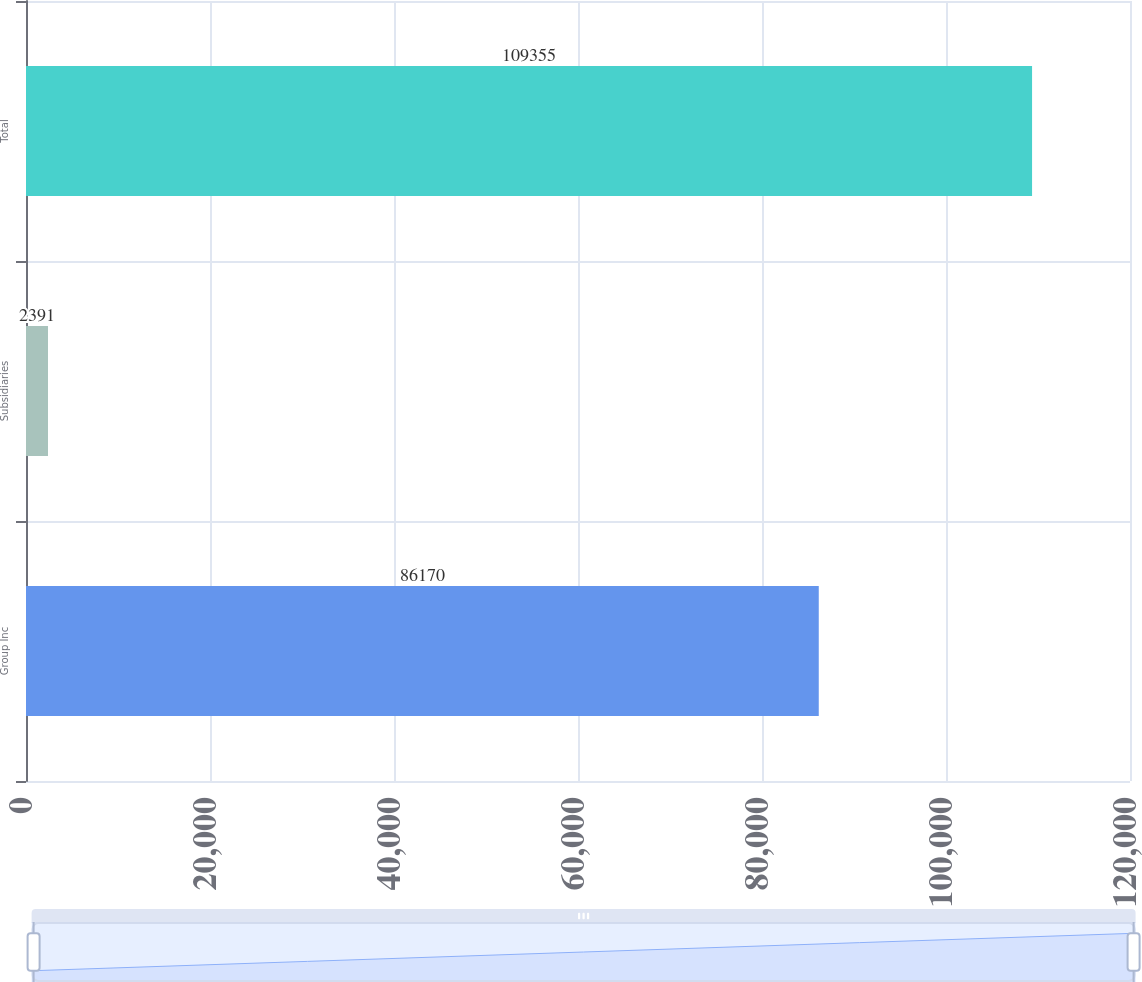<chart> <loc_0><loc_0><loc_500><loc_500><bar_chart><fcel>Group Inc<fcel>Subsidiaries<fcel>Total<nl><fcel>86170<fcel>2391<fcel>109355<nl></chart> 